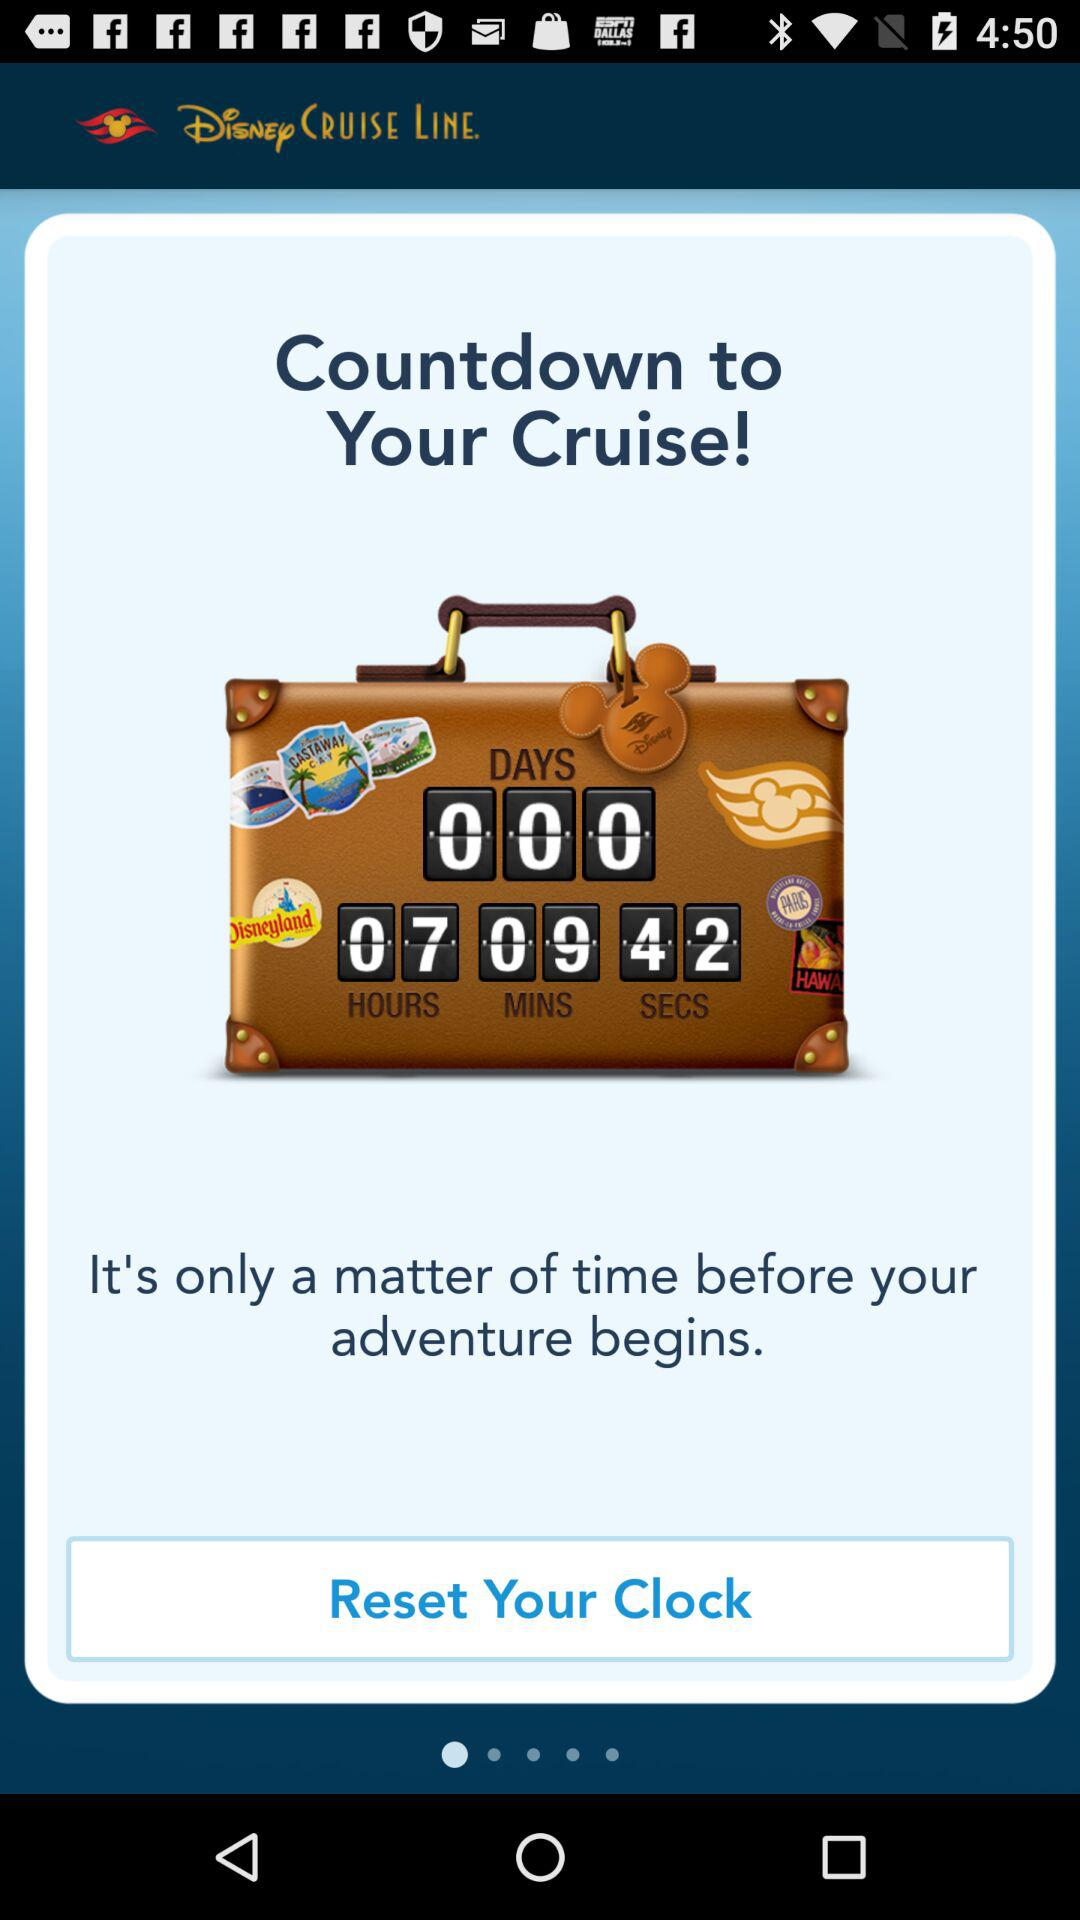What is the app name? The app name is "Disney CRUISE LINE". 